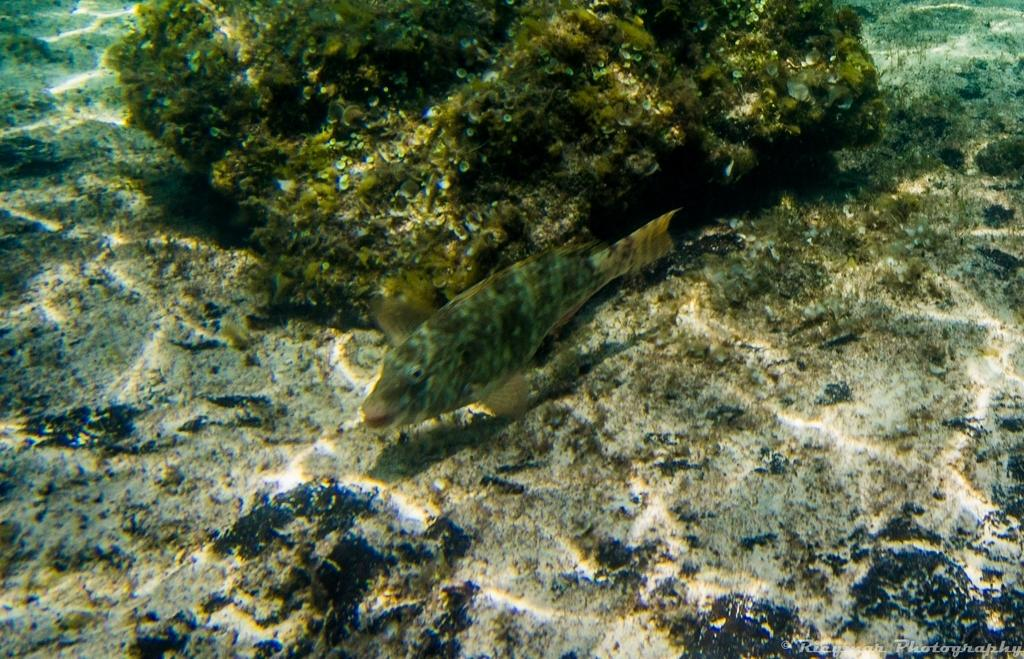What type of animal can be seen in the water in the image? There is a fish in the water in the image. What other objects or features can be seen in the water? There are corals in the water. What type of farm can be seen in the background of the image? There is no farm present in the image; it features a fish and corals in the water. What role does the tin play in the image? There is no tin present in the image. 